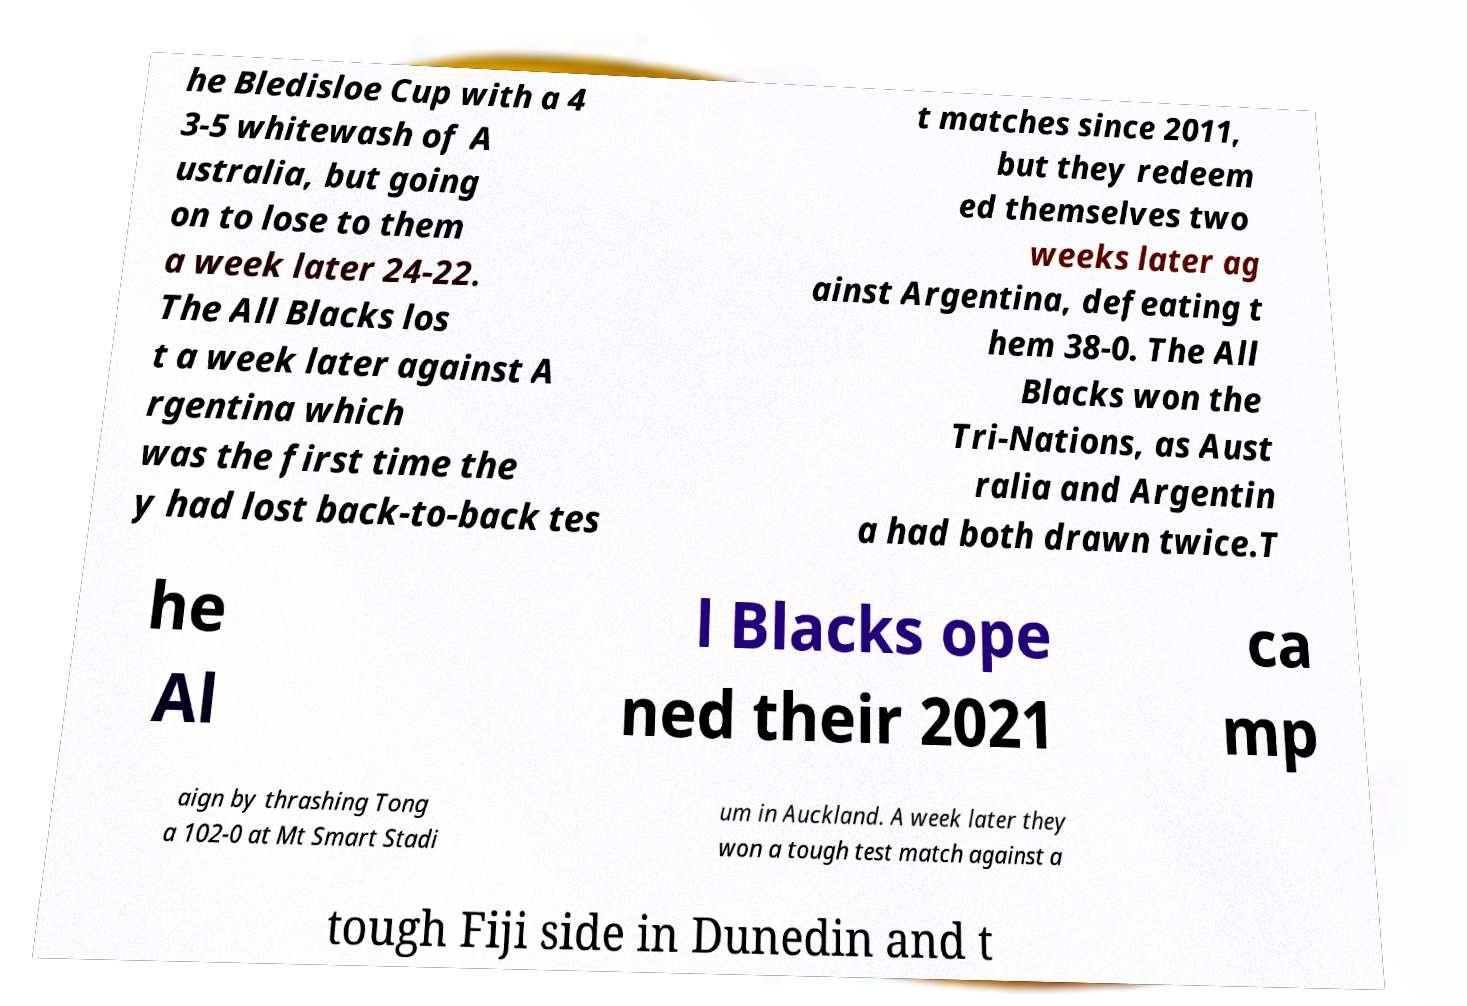Could you extract and type out the text from this image? he Bledisloe Cup with a 4 3-5 whitewash of A ustralia, but going on to lose to them a week later 24-22. The All Blacks los t a week later against A rgentina which was the first time the y had lost back-to-back tes t matches since 2011, but they redeem ed themselves two weeks later ag ainst Argentina, defeating t hem 38-0. The All Blacks won the Tri-Nations, as Aust ralia and Argentin a had both drawn twice.T he Al l Blacks ope ned their 2021 ca mp aign by thrashing Tong a 102-0 at Mt Smart Stadi um in Auckland. A week later they won a tough test match against a tough Fiji side in Dunedin and t 